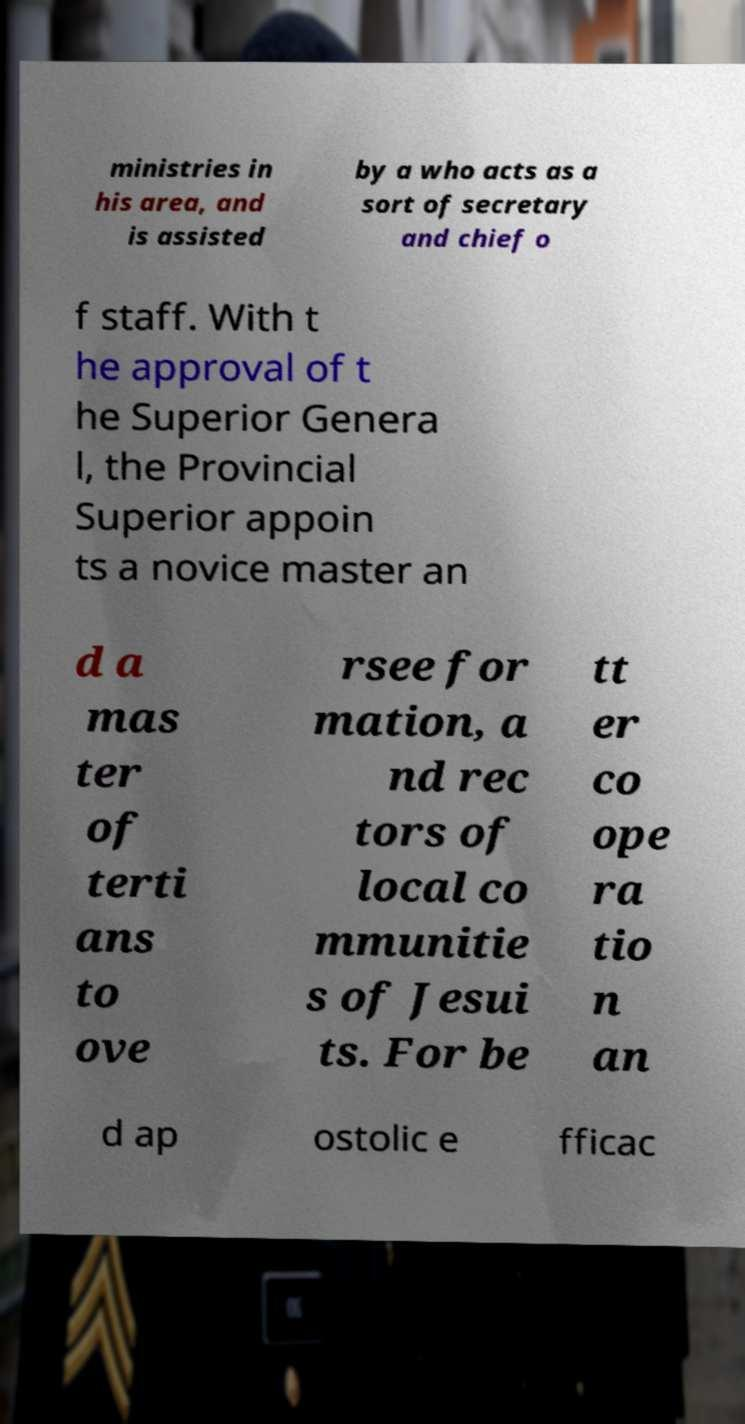Please identify and transcribe the text found in this image. ministries in his area, and is assisted by a who acts as a sort of secretary and chief o f staff. With t he approval of t he Superior Genera l, the Provincial Superior appoin ts a novice master an d a mas ter of terti ans to ove rsee for mation, a nd rec tors of local co mmunitie s of Jesui ts. For be tt er co ope ra tio n an d ap ostolic e fficac 